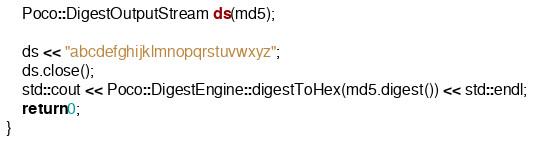Convert code to text. <code><loc_0><loc_0><loc_500><loc_500><_C++_>    Poco::DigestOutputStream ds(md5);

    ds << "abcdefghijklmnopqrstuvwxyz";
    ds.close();
    std::cout << Poco::DigestEngine::digestToHex(md5.digest()) << std::endl;
    return 0;
}</code> 